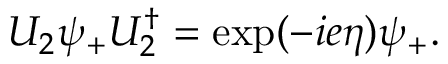Convert formula to latex. <formula><loc_0><loc_0><loc_500><loc_500>U _ { 2 } \psi _ { + } U _ { 2 } ^ { \dagger } = \exp ( - i e \eta ) \psi _ { + } .</formula> 